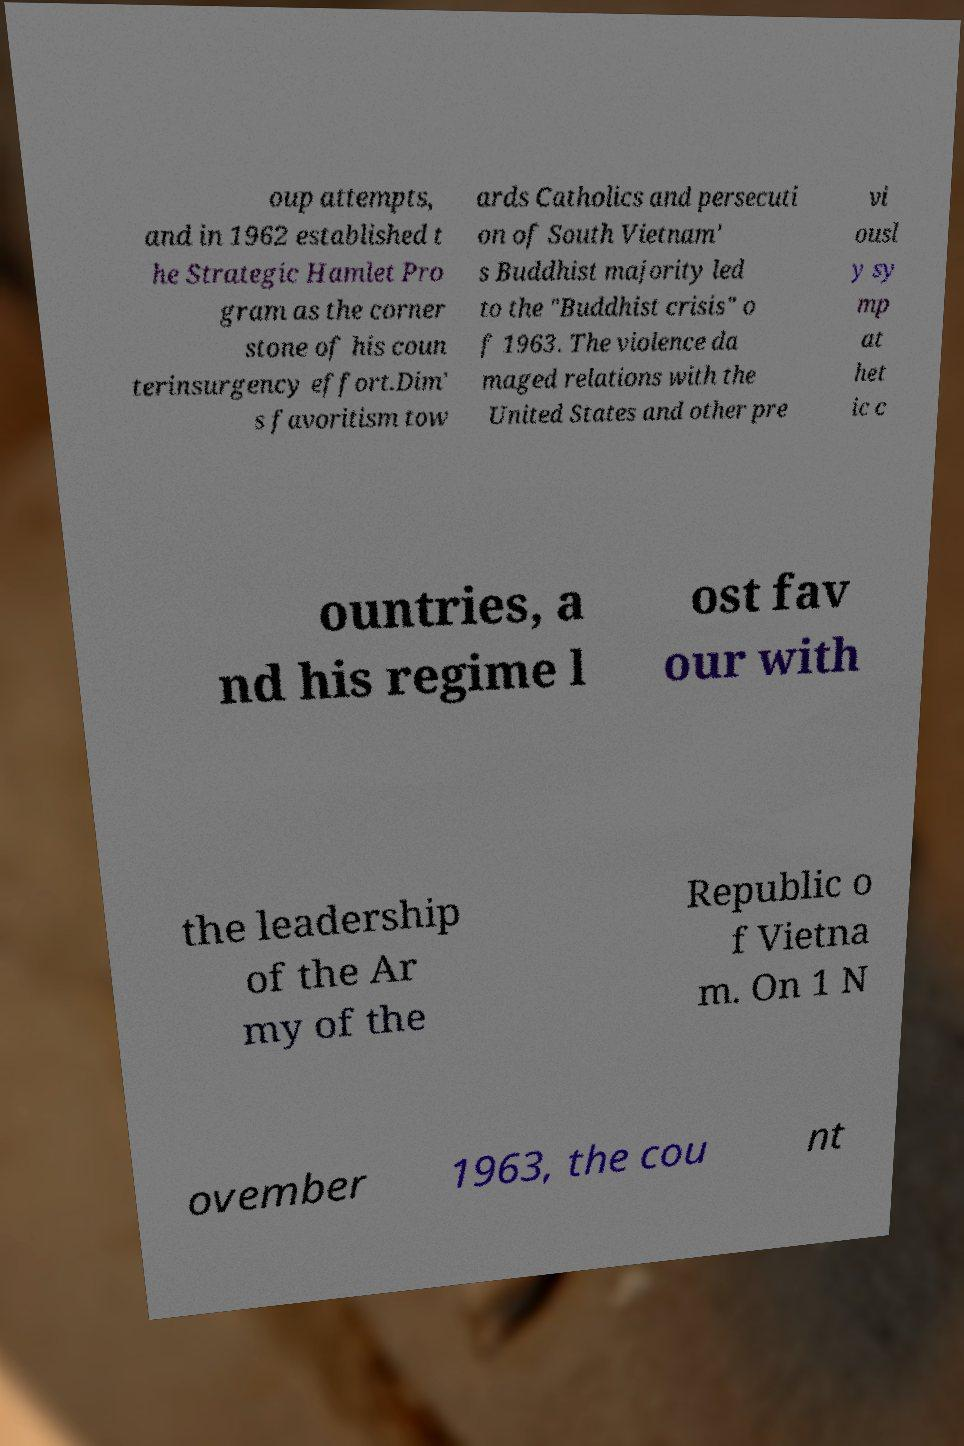Could you assist in decoding the text presented in this image and type it out clearly? oup attempts, and in 1962 established t he Strategic Hamlet Pro gram as the corner stone of his coun terinsurgency effort.Dim' s favoritism tow ards Catholics and persecuti on of South Vietnam' s Buddhist majority led to the "Buddhist crisis" o f 1963. The violence da maged relations with the United States and other pre vi ousl y sy mp at het ic c ountries, a nd his regime l ost fav our with the leadership of the Ar my of the Republic o f Vietna m. On 1 N ovember 1963, the cou nt 